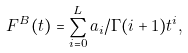Convert formula to latex. <formula><loc_0><loc_0><loc_500><loc_500>F ^ { B } ( t ) = \sum _ { i = 0 } ^ { L } a _ { i } / \Gamma ( i + 1 ) t ^ { i } ,</formula> 